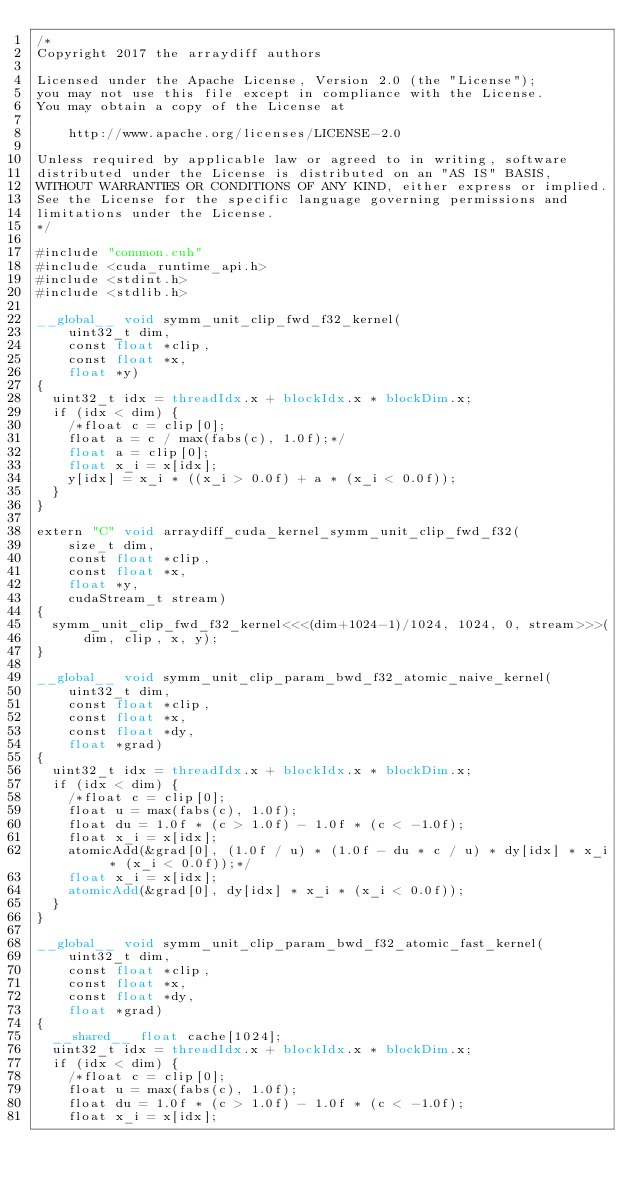<code> <loc_0><loc_0><loc_500><loc_500><_Cuda_>/*
Copyright 2017 the arraydiff authors

Licensed under the Apache License, Version 2.0 (the "License");
you may not use this file except in compliance with the License.
You may obtain a copy of the License at

    http://www.apache.org/licenses/LICENSE-2.0

Unless required by applicable law or agreed to in writing, software
distributed under the License is distributed on an "AS IS" BASIS,
WITHOUT WARRANTIES OR CONDITIONS OF ANY KIND, either express or implied.
See the License for the specific language governing permissions and
limitations under the License.
*/

#include "common.cuh"
#include <cuda_runtime_api.h>
#include <stdint.h>
#include <stdlib.h>

__global__ void symm_unit_clip_fwd_f32_kernel(
    uint32_t dim,
    const float *clip,
    const float *x,
    float *y)
{
  uint32_t idx = threadIdx.x + blockIdx.x * blockDim.x;
  if (idx < dim) {
    /*float c = clip[0];
    float a = c / max(fabs(c), 1.0f);*/
    float a = clip[0];
    float x_i = x[idx];
    y[idx] = x_i * ((x_i > 0.0f) + a * (x_i < 0.0f));
  }
}

extern "C" void arraydiff_cuda_kernel_symm_unit_clip_fwd_f32(
    size_t dim,
    const float *clip,
    const float *x,
    float *y,
    cudaStream_t stream)
{
  symm_unit_clip_fwd_f32_kernel<<<(dim+1024-1)/1024, 1024, 0, stream>>>(
      dim, clip, x, y);
}

__global__ void symm_unit_clip_param_bwd_f32_atomic_naive_kernel(
    uint32_t dim,
    const float *clip,
    const float *x,
    const float *dy,
    float *grad)
{
  uint32_t idx = threadIdx.x + blockIdx.x * blockDim.x;
  if (idx < dim) {
    /*float c = clip[0];
    float u = max(fabs(c), 1.0f);
    float du = 1.0f * (c > 1.0f) - 1.0f * (c < -1.0f);
    float x_i = x[idx];
    atomicAdd(&grad[0], (1.0f / u) * (1.0f - du * c / u) * dy[idx] * x_i * (x_i < 0.0f));*/
    float x_i = x[idx];
    atomicAdd(&grad[0], dy[idx] * x_i * (x_i < 0.0f));
  }
}

__global__ void symm_unit_clip_param_bwd_f32_atomic_fast_kernel(
    uint32_t dim,
    const float *clip,
    const float *x,
    const float *dy,
    float *grad)
{
  __shared__ float cache[1024];
  uint32_t idx = threadIdx.x + blockIdx.x * blockDim.x;
  if (idx < dim) {
    /*float c = clip[0];
    float u = max(fabs(c), 1.0f);
    float du = 1.0f * (c > 1.0f) - 1.0f * (c < -1.0f);
    float x_i = x[idx];</code> 